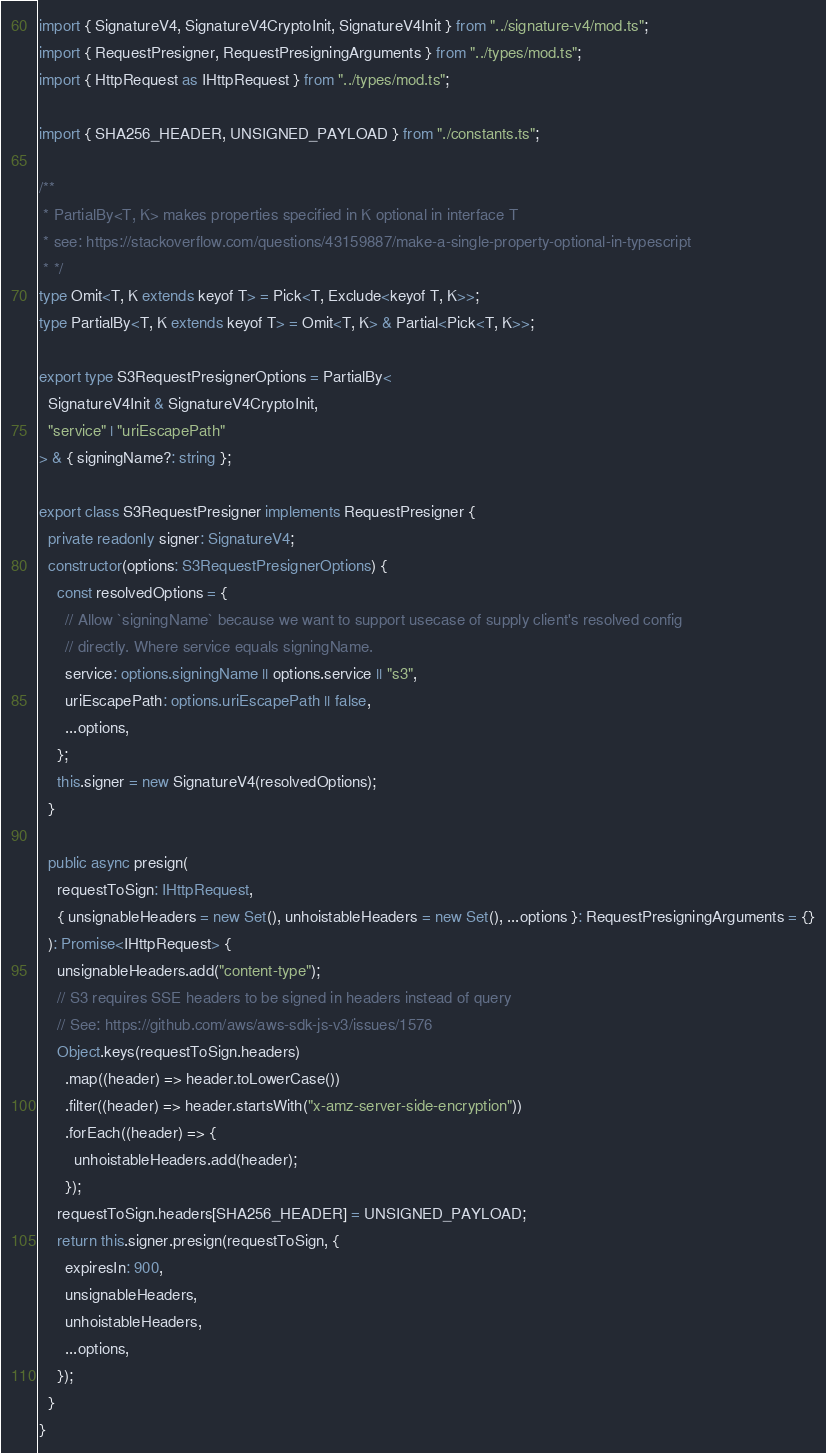<code> <loc_0><loc_0><loc_500><loc_500><_TypeScript_>import { SignatureV4, SignatureV4CryptoInit, SignatureV4Init } from "../signature-v4/mod.ts";
import { RequestPresigner, RequestPresigningArguments } from "../types/mod.ts";
import { HttpRequest as IHttpRequest } from "../types/mod.ts";

import { SHA256_HEADER, UNSIGNED_PAYLOAD } from "./constants.ts";

/**
 * PartialBy<T, K> makes properties specified in K optional in interface T
 * see: https://stackoverflow.com/questions/43159887/make-a-single-property-optional-in-typescript
 * */
type Omit<T, K extends keyof T> = Pick<T, Exclude<keyof T, K>>;
type PartialBy<T, K extends keyof T> = Omit<T, K> & Partial<Pick<T, K>>;

export type S3RequestPresignerOptions = PartialBy<
  SignatureV4Init & SignatureV4CryptoInit,
  "service" | "uriEscapePath"
> & { signingName?: string };

export class S3RequestPresigner implements RequestPresigner {
  private readonly signer: SignatureV4;
  constructor(options: S3RequestPresignerOptions) {
    const resolvedOptions = {
      // Allow `signingName` because we want to support usecase of supply client's resolved config
      // directly. Where service equals signingName.
      service: options.signingName || options.service || "s3",
      uriEscapePath: options.uriEscapePath || false,
      ...options,
    };
    this.signer = new SignatureV4(resolvedOptions);
  }

  public async presign(
    requestToSign: IHttpRequest,
    { unsignableHeaders = new Set(), unhoistableHeaders = new Set(), ...options }: RequestPresigningArguments = {}
  ): Promise<IHttpRequest> {
    unsignableHeaders.add("content-type");
    // S3 requires SSE headers to be signed in headers instead of query
    // See: https://github.com/aws/aws-sdk-js-v3/issues/1576
    Object.keys(requestToSign.headers)
      .map((header) => header.toLowerCase())
      .filter((header) => header.startsWith("x-amz-server-side-encryption"))
      .forEach((header) => {
        unhoistableHeaders.add(header);
      });
    requestToSign.headers[SHA256_HEADER] = UNSIGNED_PAYLOAD;
    return this.signer.presign(requestToSign, {
      expiresIn: 900,
      unsignableHeaders,
      unhoistableHeaders,
      ...options,
    });
  }
}
</code> 